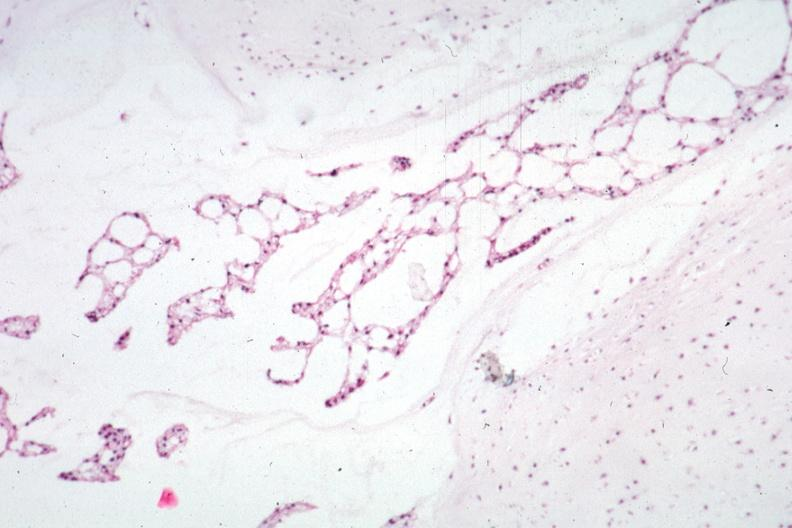does this image show micro low mag h&e would have to get protocol to determine where this section was taken?
Answer the question using a single word or phrase. Yes 